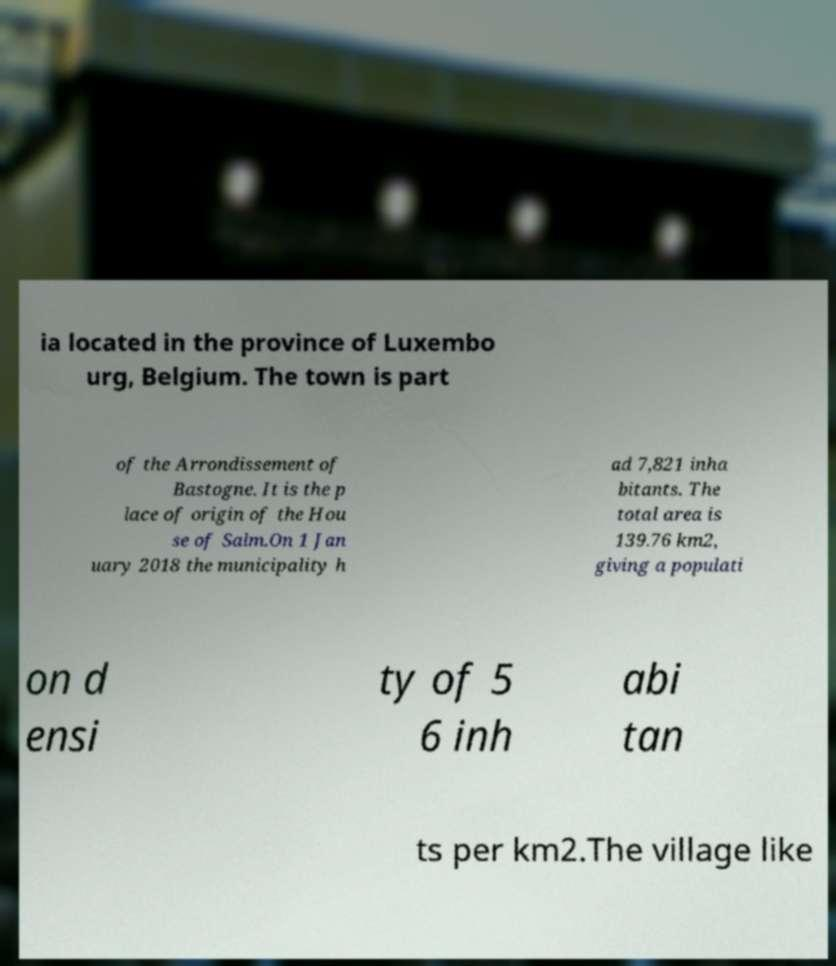Please identify and transcribe the text found in this image. ia located in the province of Luxembo urg, Belgium. The town is part of the Arrondissement of Bastogne. It is the p lace of origin of the Hou se of Salm.On 1 Jan uary 2018 the municipality h ad 7,821 inha bitants. The total area is 139.76 km2, giving a populati on d ensi ty of 5 6 inh abi tan ts per km2.The village like 